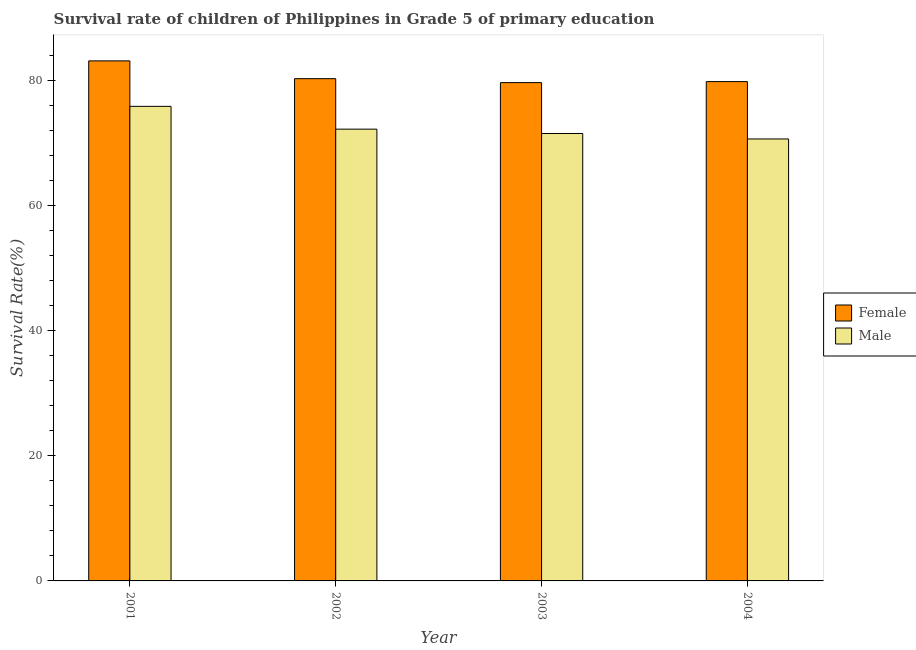How many different coloured bars are there?
Offer a very short reply. 2. How many groups of bars are there?
Offer a very short reply. 4. Are the number of bars on each tick of the X-axis equal?
Your answer should be compact. Yes. How many bars are there on the 1st tick from the right?
Provide a succinct answer. 2. What is the survival rate of female students in primary education in 2001?
Give a very brief answer. 83.08. Across all years, what is the maximum survival rate of male students in primary education?
Provide a succinct answer. 75.81. Across all years, what is the minimum survival rate of female students in primary education?
Keep it short and to the point. 79.6. What is the total survival rate of female students in primary education in the graph?
Provide a succinct answer. 322.68. What is the difference between the survival rate of female students in primary education in 2001 and that in 2003?
Give a very brief answer. 3.47. What is the difference between the survival rate of male students in primary education in 2001 and the survival rate of female students in primary education in 2003?
Offer a terse response. 4.33. What is the average survival rate of male students in primary education per year?
Your response must be concise. 72.51. In how many years, is the survival rate of male students in primary education greater than 8 %?
Your answer should be compact. 4. What is the ratio of the survival rate of female students in primary education in 2001 to that in 2004?
Offer a terse response. 1.04. Is the survival rate of male students in primary education in 2001 less than that in 2002?
Provide a short and direct response. No. Is the difference between the survival rate of male students in primary education in 2002 and 2004 greater than the difference between the survival rate of female students in primary education in 2002 and 2004?
Keep it short and to the point. No. What is the difference between the highest and the second highest survival rate of male students in primary education?
Give a very brief answer. 3.64. What is the difference between the highest and the lowest survival rate of male students in primary education?
Your answer should be very brief. 5.21. Is the sum of the survival rate of female students in primary education in 2001 and 2002 greater than the maximum survival rate of male students in primary education across all years?
Make the answer very short. Yes. What does the 1st bar from the left in 2004 represents?
Offer a very short reply. Female. What does the 2nd bar from the right in 2003 represents?
Ensure brevity in your answer.  Female. How many bars are there?
Provide a succinct answer. 8. How many years are there in the graph?
Provide a short and direct response. 4. What is the difference between two consecutive major ticks on the Y-axis?
Offer a very short reply. 20. Does the graph contain grids?
Provide a succinct answer. No. Where does the legend appear in the graph?
Offer a terse response. Center right. How many legend labels are there?
Your answer should be very brief. 2. What is the title of the graph?
Keep it short and to the point. Survival rate of children of Philippines in Grade 5 of primary education. Does "Official creditors" appear as one of the legend labels in the graph?
Provide a succinct answer. No. What is the label or title of the Y-axis?
Ensure brevity in your answer.  Survival Rate(%). What is the Survival Rate(%) of Female in 2001?
Offer a very short reply. 83.08. What is the Survival Rate(%) of Male in 2001?
Provide a short and direct response. 75.81. What is the Survival Rate(%) in Female in 2002?
Provide a succinct answer. 80.23. What is the Survival Rate(%) in Male in 2002?
Your response must be concise. 72.17. What is the Survival Rate(%) in Female in 2003?
Keep it short and to the point. 79.6. What is the Survival Rate(%) in Male in 2003?
Give a very brief answer. 71.48. What is the Survival Rate(%) of Female in 2004?
Your response must be concise. 79.77. What is the Survival Rate(%) in Male in 2004?
Provide a short and direct response. 70.6. Across all years, what is the maximum Survival Rate(%) in Female?
Make the answer very short. 83.08. Across all years, what is the maximum Survival Rate(%) of Male?
Ensure brevity in your answer.  75.81. Across all years, what is the minimum Survival Rate(%) in Female?
Keep it short and to the point. 79.6. Across all years, what is the minimum Survival Rate(%) of Male?
Provide a succinct answer. 70.6. What is the total Survival Rate(%) in Female in the graph?
Offer a very short reply. 322.68. What is the total Survival Rate(%) in Male in the graph?
Make the answer very short. 290.06. What is the difference between the Survival Rate(%) of Female in 2001 and that in 2002?
Your answer should be very brief. 2.84. What is the difference between the Survival Rate(%) in Male in 2001 and that in 2002?
Provide a short and direct response. 3.64. What is the difference between the Survival Rate(%) in Female in 2001 and that in 2003?
Provide a short and direct response. 3.47. What is the difference between the Survival Rate(%) of Male in 2001 and that in 2003?
Your answer should be very brief. 4.33. What is the difference between the Survival Rate(%) in Female in 2001 and that in 2004?
Your answer should be very brief. 3.31. What is the difference between the Survival Rate(%) in Male in 2001 and that in 2004?
Provide a short and direct response. 5.21. What is the difference between the Survival Rate(%) of Female in 2002 and that in 2003?
Provide a short and direct response. 0.63. What is the difference between the Survival Rate(%) of Male in 2002 and that in 2003?
Make the answer very short. 0.69. What is the difference between the Survival Rate(%) in Female in 2002 and that in 2004?
Offer a terse response. 0.47. What is the difference between the Survival Rate(%) of Male in 2002 and that in 2004?
Your answer should be very brief. 1.57. What is the difference between the Survival Rate(%) of Female in 2003 and that in 2004?
Give a very brief answer. -0.16. What is the difference between the Survival Rate(%) in Male in 2003 and that in 2004?
Offer a terse response. 0.88. What is the difference between the Survival Rate(%) of Female in 2001 and the Survival Rate(%) of Male in 2002?
Ensure brevity in your answer.  10.91. What is the difference between the Survival Rate(%) in Female in 2001 and the Survival Rate(%) in Male in 2003?
Offer a very short reply. 11.6. What is the difference between the Survival Rate(%) in Female in 2001 and the Survival Rate(%) in Male in 2004?
Make the answer very short. 12.47. What is the difference between the Survival Rate(%) in Female in 2002 and the Survival Rate(%) in Male in 2003?
Your answer should be compact. 8.76. What is the difference between the Survival Rate(%) in Female in 2002 and the Survival Rate(%) in Male in 2004?
Ensure brevity in your answer.  9.63. What is the difference between the Survival Rate(%) in Female in 2003 and the Survival Rate(%) in Male in 2004?
Ensure brevity in your answer.  9. What is the average Survival Rate(%) of Female per year?
Provide a short and direct response. 80.67. What is the average Survival Rate(%) in Male per year?
Make the answer very short. 72.51. In the year 2001, what is the difference between the Survival Rate(%) of Female and Survival Rate(%) of Male?
Offer a very short reply. 7.27. In the year 2002, what is the difference between the Survival Rate(%) of Female and Survival Rate(%) of Male?
Offer a very short reply. 8.06. In the year 2003, what is the difference between the Survival Rate(%) of Female and Survival Rate(%) of Male?
Your answer should be compact. 8.13. In the year 2004, what is the difference between the Survival Rate(%) of Female and Survival Rate(%) of Male?
Keep it short and to the point. 9.16. What is the ratio of the Survival Rate(%) of Female in 2001 to that in 2002?
Keep it short and to the point. 1.04. What is the ratio of the Survival Rate(%) in Male in 2001 to that in 2002?
Give a very brief answer. 1.05. What is the ratio of the Survival Rate(%) in Female in 2001 to that in 2003?
Your answer should be compact. 1.04. What is the ratio of the Survival Rate(%) in Male in 2001 to that in 2003?
Provide a short and direct response. 1.06. What is the ratio of the Survival Rate(%) in Female in 2001 to that in 2004?
Ensure brevity in your answer.  1.04. What is the ratio of the Survival Rate(%) of Male in 2001 to that in 2004?
Your answer should be very brief. 1.07. What is the ratio of the Survival Rate(%) of Female in 2002 to that in 2003?
Your answer should be very brief. 1.01. What is the ratio of the Survival Rate(%) in Male in 2002 to that in 2003?
Your answer should be very brief. 1.01. What is the ratio of the Survival Rate(%) of Female in 2002 to that in 2004?
Provide a succinct answer. 1.01. What is the ratio of the Survival Rate(%) in Male in 2002 to that in 2004?
Ensure brevity in your answer.  1.02. What is the ratio of the Survival Rate(%) in Male in 2003 to that in 2004?
Give a very brief answer. 1.01. What is the difference between the highest and the second highest Survival Rate(%) of Female?
Keep it short and to the point. 2.84. What is the difference between the highest and the second highest Survival Rate(%) in Male?
Your response must be concise. 3.64. What is the difference between the highest and the lowest Survival Rate(%) in Female?
Ensure brevity in your answer.  3.47. What is the difference between the highest and the lowest Survival Rate(%) of Male?
Keep it short and to the point. 5.21. 